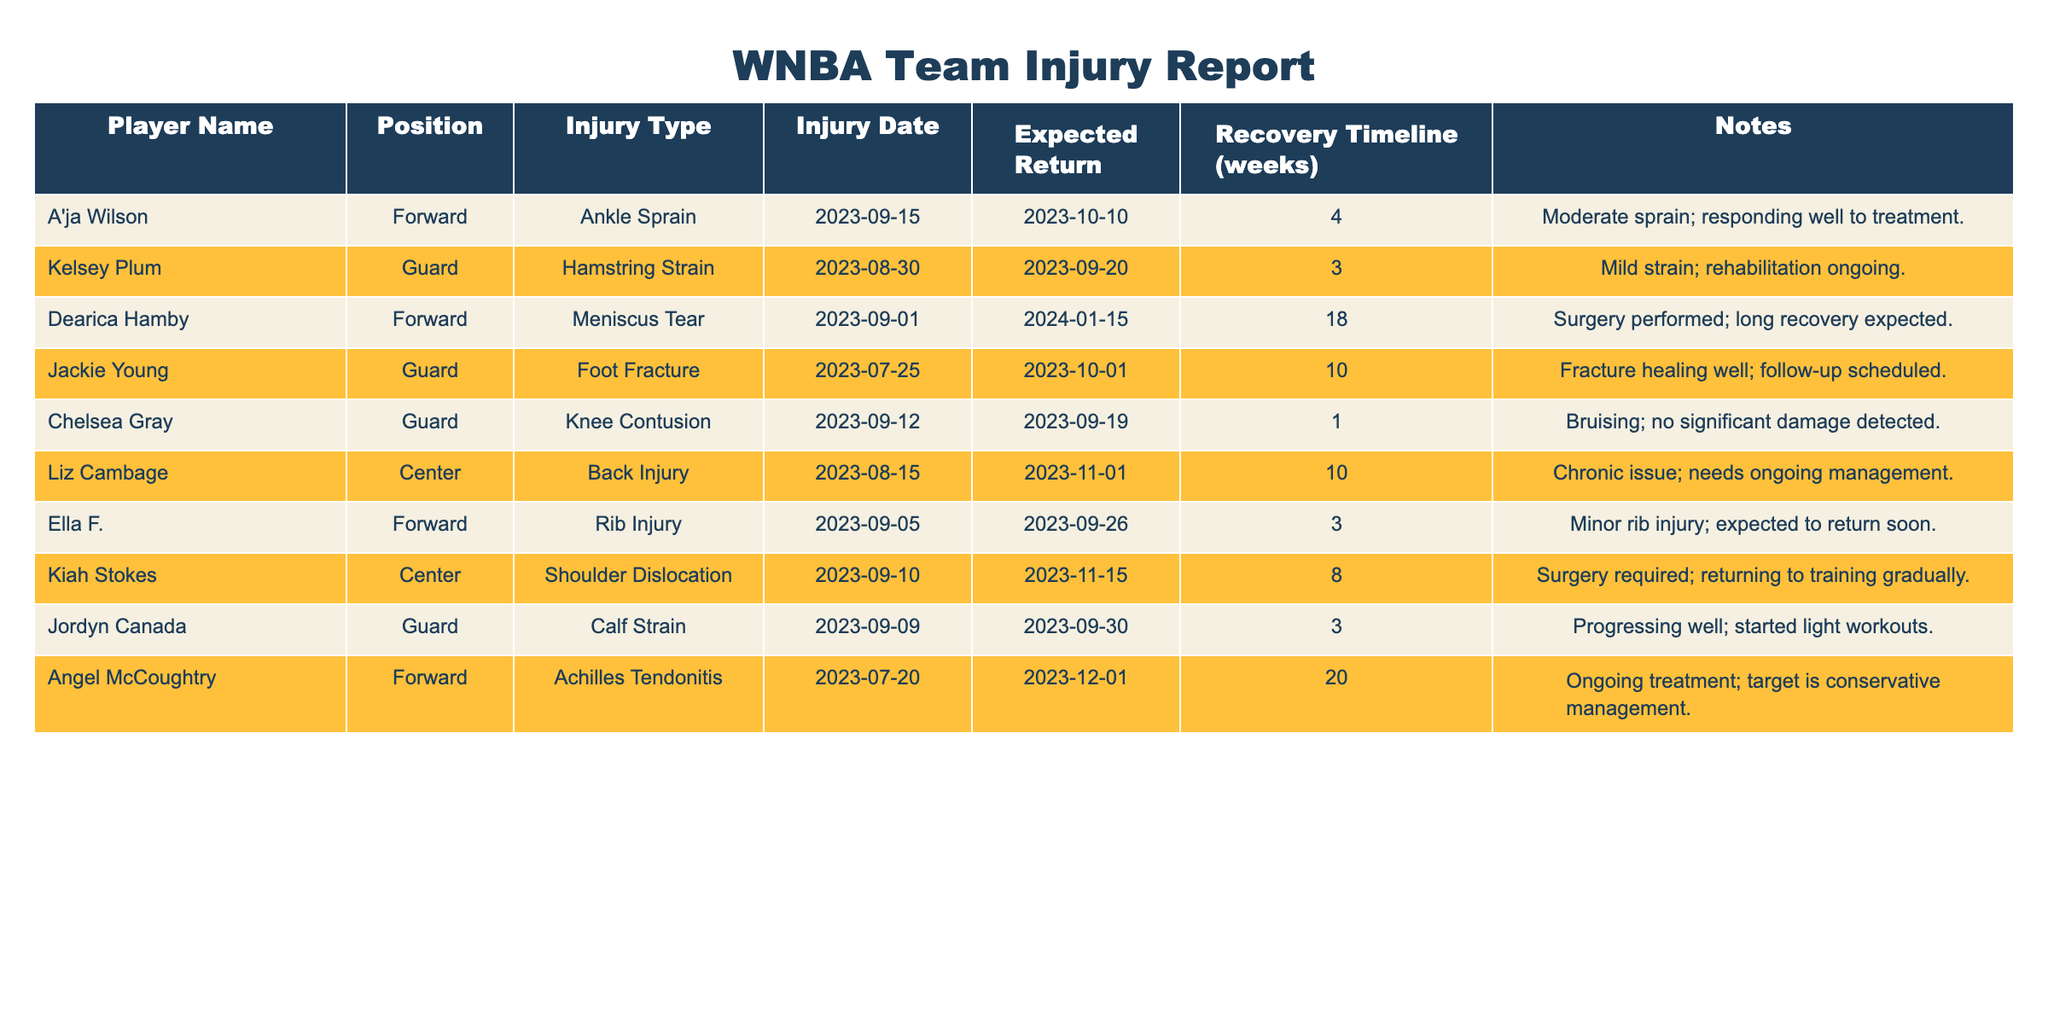What injury does A'ja Wilson have? The table states that A'ja Wilson has an Ankle Sprain.
Answer: Ankle Sprain What is Kelsey Plum's expected return date? Looking at the table, Kelsey Plum's expected return date is 2023-09-20.
Answer: 2023-09-20 How many weeks is Dearica Hamby's recovery timeline? The table shows that Dearica Hamby's recovery timeline is 18 weeks.
Answer: 18 weeks Is Chelsea Gray's injury a significant damage? According to the notes in the table, Chelsea Gray's injury is a knee contusion with no significant damage detected.
Answer: Yes Which player has the longest recovery timeline? By comparing the recovery timelines listed, Dearica Hamby has the longest recovery timeline of 18 weeks.
Answer: Dearica Hamby What is the expected return date for Liz Cambage? The table indicates that Liz Cambage is expected to return on 2023-11-01.
Answer: 2023-11-01 Are there any players expected to return in less than 4 weeks? Checking the table, Chelsea Gray, Ella F., and Kelsey Plum are all expected to return in less than 4 weeks (1-3 weeks).
Answer: Yes Which injury has the longest recovery period, and what is it? Reviewing the recovery timelines, Angel McCoughtry has an Achilles Tendonitis with a recovery period of 20 weeks, which is the longest.
Answer: Achilles Tendonitis, 20 weeks How many players have injuries that require surgery? The table shows that Kiah Stokes and Dearica Hamby both require surgery for their injuries. Therefore, there are two players.
Answer: 2 players What is the sum of the expected return dates for all players? As expected return dates are dates, not numerical values, this question is not applicable as it cannot be summed.
Answer: N/A 